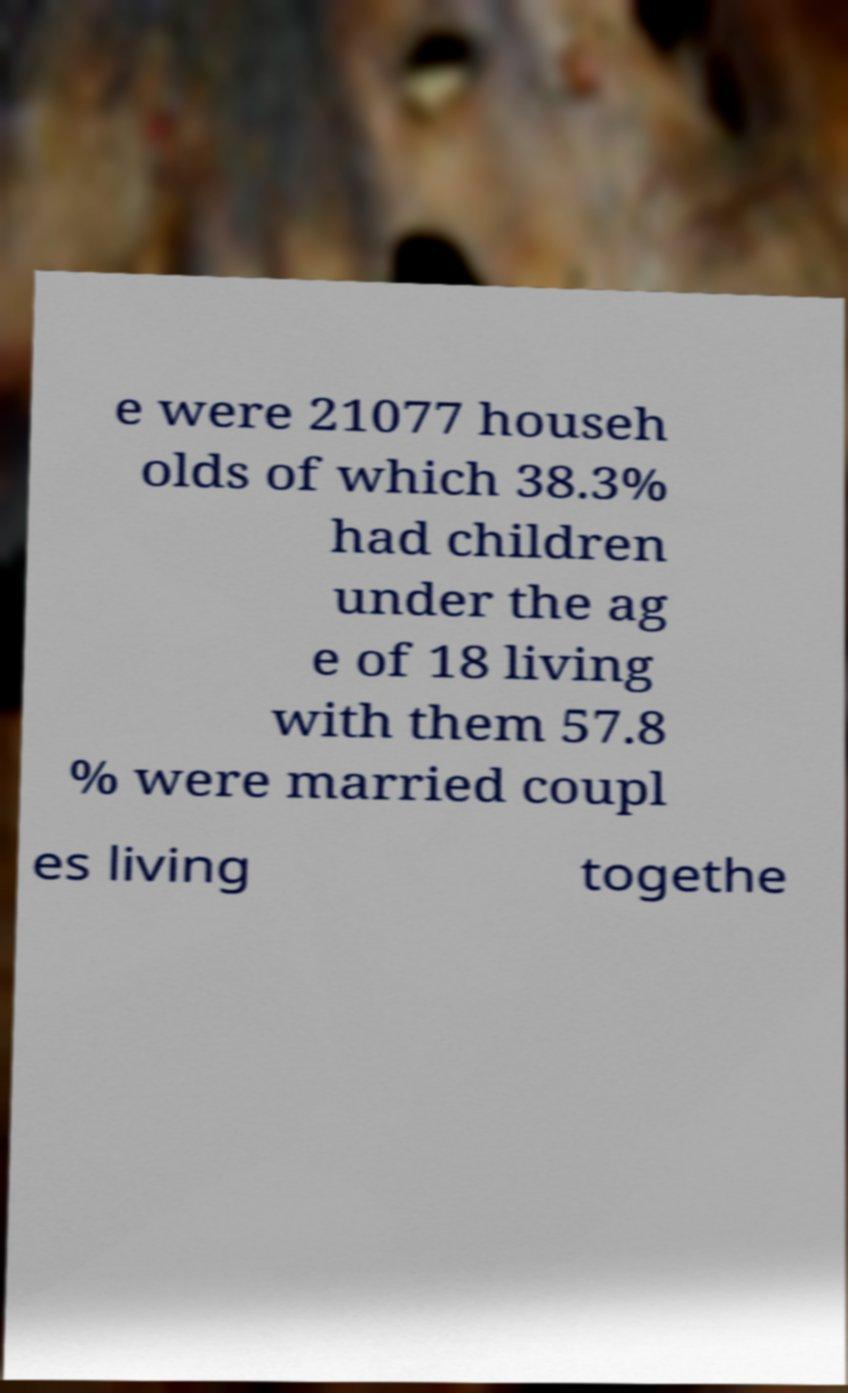Could you extract and type out the text from this image? e were 21077 househ olds of which 38.3% had children under the ag e of 18 living with them 57.8 % were married coupl es living togethe 